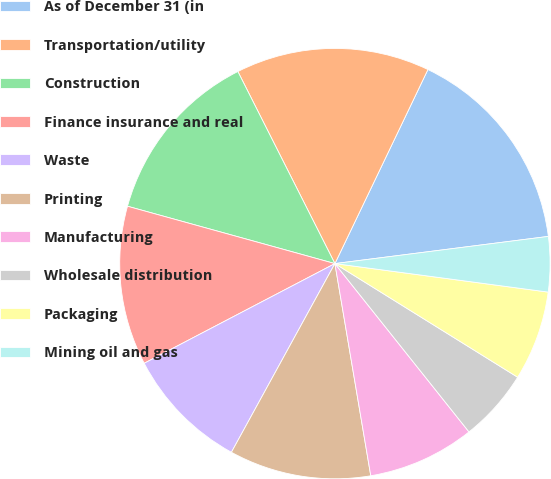Convert chart. <chart><loc_0><loc_0><loc_500><loc_500><pie_chart><fcel>As of December 31 (in<fcel>Transportation/utility<fcel>Construction<fcel>Finance insurance and real<fcel>Waste<fcel>Printing<fcel>Manufacturing<fcel>Wholesale distribution<fcel>Packaging<fcel>Mining oil and gas<nl><fcel>15.87%<fcel>14.56%<fcel>13.26%<fcel>11.96%<fcel>9.35%<fcel>10.65%<fcel>8.04%<fcel>5.44%<fcel>6.74%<fcel>4.13%<nl></chart> 